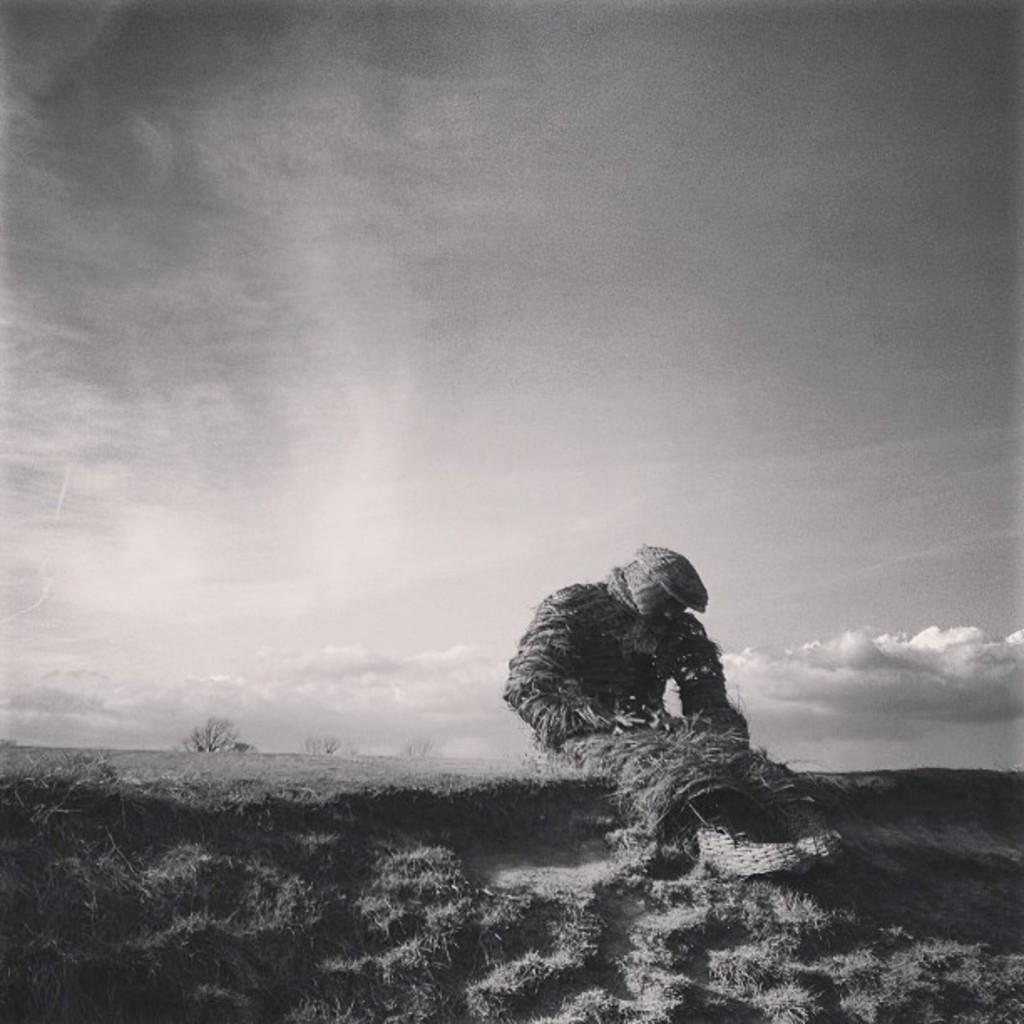What is the color scheme of the image? The image is black and white. What figure can be seen in the image? There is a straw man in the image. What type of vegetation is present in the image? There is grass in the image. What can be seen in the background of the image? There is a tree in the background of the image. What is visible in the sky in the image? Clouds are visible in the sky. How many rings does the straw man have on its stomach in the image? There are no rings visible on the straw man's stomach in the image, as it is a simple figure made of straw. 